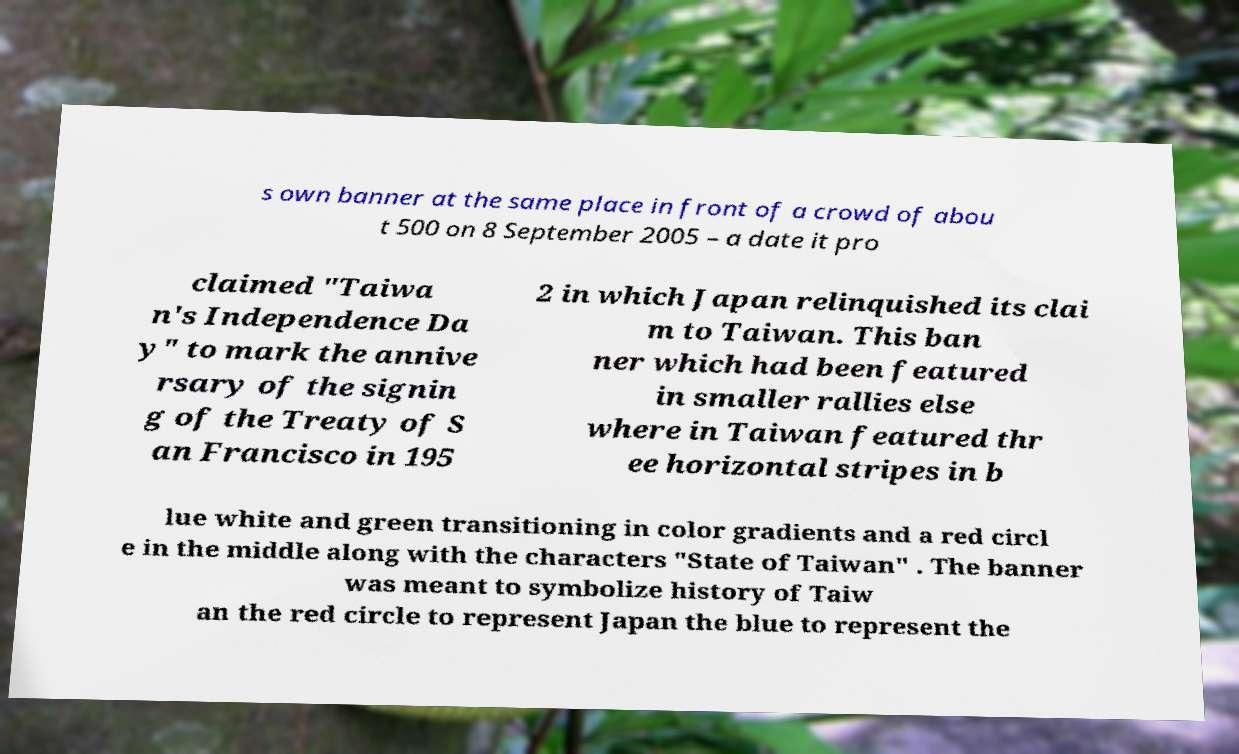Could you assist in decoding the text presented in this image and type it out clearly? s own banner at the same place in front of a crowd of abou t 500 on 8 September 2005 – a date it pro claimed "Taiwa n's Independence Da y" to mark the annive rsary of the signin g of the Treaty of S an Francisco in 195 2 in which Japan relinquished its clai m to Taiwan. This ban ner which had been featured in smaller rallies else where in Taiwan featured thr ee horizontal stripes in b lue white and green transitioning in color gradients and a red circl e in the middle along with the characters "State of Taiwan" . The banner was meant to symbolize history of Taiw an the red circle to represent Japan the blue to represent the 